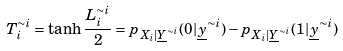Convert formula to latex. <formula><loc_0><loc_0><loc_500><loc_500>T _ { i } ^ { \sim i } = \tanh \frac { L _ { i } ^ { \sim i } } { 2 } = p _ { X _ { i } | \underline { Y } ^ { \sim i } } ( 0 | \underline { y } ^ { \sim i } ) - p _ { X _ { i } | \underline { Y } ^ { \sim i } } ( 1 | \underline { y } ^ { \sim i } )</formula> 